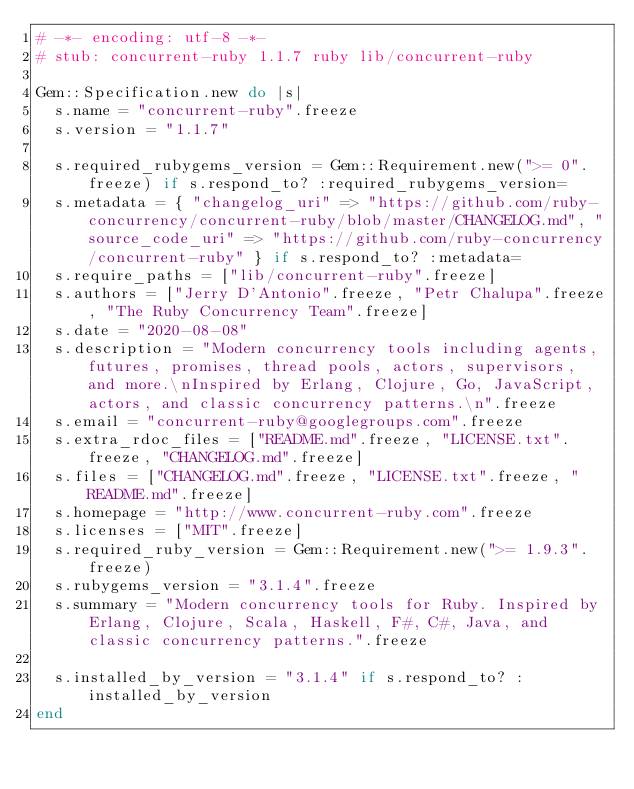Convert code to text. <code><loc_0><loc_0><loc_500><loc_500><_Ruby_># -*- encoding: utf-8 -*-
# stub: concurrent-ruby 1.1.7 ruby lib/concurrent-ruby

Gem::Specification.new do |s|
  s.name = "concurrent-ruby".freeze
  s.version = "1.1.7"

  s.required_rubygems_version = Gem::Requirement.new(">= 0".freeze) if s.respond_to? :required_rubygems_version=
  s.metadata = { "changelog_uri" => "https://github.com/ruby-concurrency/concurrent-ruby/blob/master/CHANGELOG.md", "source_code_uri" => "https://github.com/ruby-concurrency/concurrent-ruby" } if s.respond_to? :metadata=
  s.require_paths = ["lib/concurrent-ruby".freeze]
  s.authors = ["Jerry D'Antonio".freeze, "Petr Chalupa".freeze, "The Ruby Concurrency Team".freeze]
  s.date = "2020-08-08"
  s.description = "Modern concurrency tools including agents, futures, promises, thread pools, actors, supervisors, and more.\nInspired by Erlang, Clojure, Go, JavaScript, actors, and classic concurrency patterns.\n".freeze
  s.email = "concurrent-ruby@googlegroups.com".freeze
  s.extra_rdoc_files = ["README.md".freeze, "LICENSE.txt".freeze, "CHANGELOG.md".freeze]
  s.files = ["CHANGELOG.md".freeze, "LICENSE.txt".freeze, "README.md".freeze]
  s.homepage = "http://www.concurrent-ruby.com".freeze
  s.licenses = ["MIT".freeze]
  s.required_ruby_version = Gem::Requirement.new(">= 1.9.3".freeze)
  s.rubygems_version = "3.1.4".freeze
  s.summary = "Modern concurrency tools for Ruby. Inspired by Erlang, Clojure, Scala, Haskell, F#, C#, Java, and classic concurrency patterns.".freeze

  s.installed_by_version = "3.1.4" if s.respond_to? :installed_by_version
end
</code> 